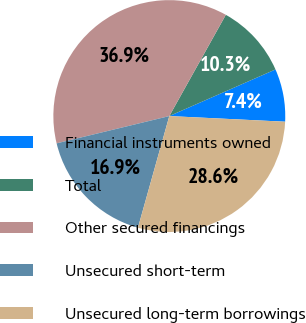Convert chart. <chart><loc_0><loc_0><loc_500><loc_500><pie_chart><fcel>Financial instruments owned<fcel>Total<fcel>Other secured financings<fcel>Unsecured short-term<fcel>Unsecured long-term borrowings<nl><fcel>7.36%<fcel>10.31%<fcel>36.88%<fcel>16.86%<fcel>28.58%<nl></chart> 